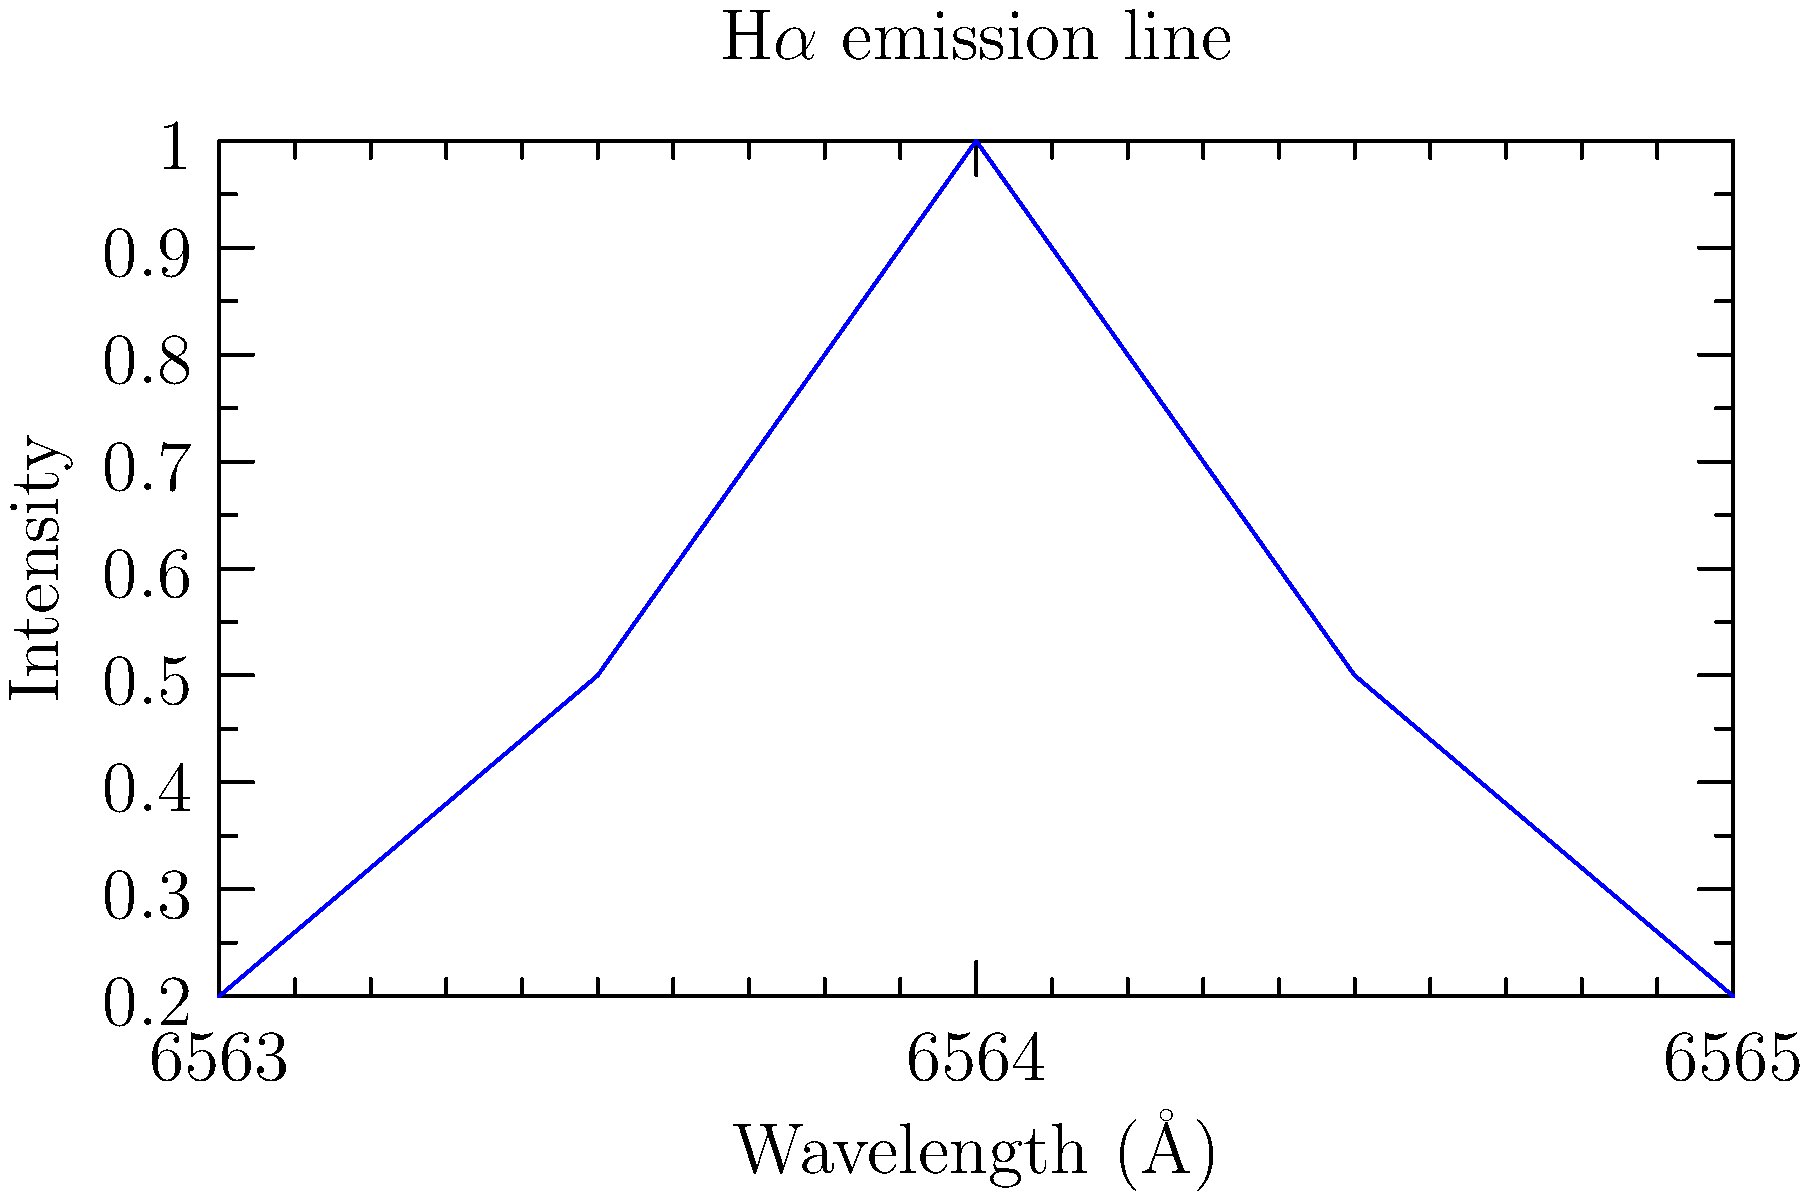A spectroscopic observation of a distant galaxy reveals a shifted H$\alpha$ emission line, as shown in the graph. Given that the rest wavelength of H$\alpha$ is 6562.8 Å, and assuming the shift is entirely due to the galaxy's rotation, calculate the rotational velocity of the galaxy in km/s. Use $c = 3 \times 10^5$ km/s for the speed of light. To calculate the rotational velocity of the galaxy, we'll use the Doppler shift formula and follow these steps:

1) Identify the observed wavelength ($\lambda_{obs}$):
   From the graph, the peak of the H$\alpha$ line is at 6564.0 Å.

2) Calculate the wavelength shift ($\Delta \lambda$):
   $\Delta \lambda = \lambda_{obs} - \lambda_{rest}$
   $\Delta \lambda = 6564.0 \text{ Å} - 6562.8 \text{ Å} = 1.2 \text{ Å}$

3) Use the Doppler shift formula:
   $\frac{\Delta \lambda}{\lambda_{rest}} = \frac{v}{c}$

4) Rearrange to solve for velocity (v):
   $v = c \times \frac{\Delta \lambda}{\lambda_{rest}}$

5) Substitute the values:
   $v = 3 \times 10^5 \text{ km/s} \times \frac{1.2 \text{ Å}}{6562.8 \text{ Å}}$

6) Calculate the result:
   $v = 54.85 \text{ km/s}$

Therefore, the rotational velocity of the galaxy is approximately 54.85 km/s.
Answer: 54.85 km/s 